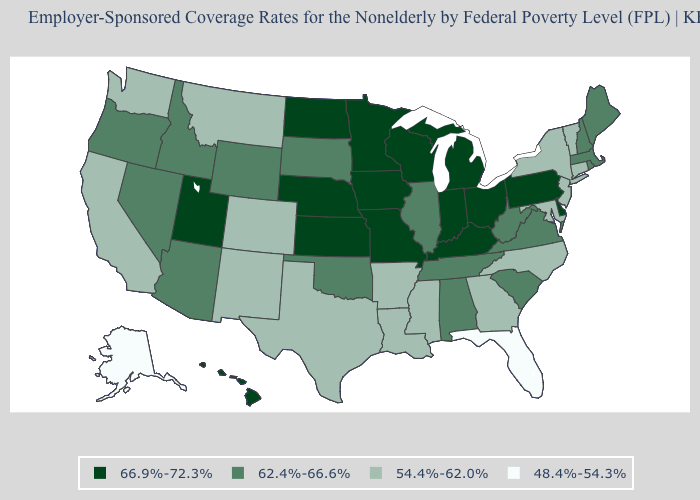Which states have the lowest value in the USA?
Keep it brief. Alaska, Florida. Name the states that have a value in the range 62.4%-66.6%?
Answer briefly. Alabama, Arizona, Idaho, Illinois, Maine, Massachusetts, Nevada, New Hampshire, Oklahoma, Oregon, Rhode Island, South Carolina, South Dakota, Tennessee, Virginia, West Virginia, Wyoming. Does Vermont have a higher value than Alaska?
Keep it brief. Yes. Name the states that have a value in the range 54.4%-62.0%?
Keep it brief. Arkansas, California, Colorado, Connecticut, Georgia, Louisiana, Maryland, Mississippi, Montana, New Jersey, New Mexico, New York, North Carolina, Texas, Vermont, Washington. Does Arizona have the lowest value in the USA?
Give a very brief answer. No. Does Pennsylvania have the same value as Ohio?
Short answer required. Yes. Name the states that have a value in the range 62.4%-66.6%?
Keep it brief. Alabama, Arizona, Idaho, Illinois, Maine, Massachusetts, Nevada, New Hampshire, Oklahoma, Oregon, Rhode Island, South Carolina, South Dakota, Tennessee, Virginia, West Virginia, Wyoming. Name the states that have a value in the range 62.4%-66.6%?
Short answer required. Alabama, Arizona, Idaho, Illinois, Maine, Massachusetts, Nevada, New Hampshire, Oklahoma, Oregon, Rhode Island, South Carolina, South Dakota, Tennessee, Virginia, West Virginia, Wyoming. Name the states that have a value in the range 66.9%-72.3%?
Keep it brief. Delaware, Hawaii, Indiana, Iowa, Kansas, Kentucky, Michigan, Minnesota, Missouri, Nebraska, North Dakota, Ohio, Pennsylvania, Utah, Wisconsin. What is the value of Georgia?
Write a very short answer. 54.4%-62.0%. Does Kansas have the highest value in the USA?
Be succinct. Yes. Name the states that have a value in the range 62.4%-66.6%?
Concise answer only. Alabama, Arizona, Idaho, Illinois, Maine, Massachusetts, Nevada, New Hampshire, Oklahoma, Oregon, Rhode Island, South Carolina, South Dakota, Tennessee, Virginia, West Virginia, Wyoming. Does Oklahoma have the highest value in the South?
Answer briefly. No. What is the value of New York?
Answer briefly. 54.4%-62.0%. Name the states that have a value in the range 54.4%-62.0%?
Give a very brief answer. Arkansas, California, Colorado, Connecticut, Georgia, Louisiana, Maryland, Mississippi, Montana, New Jersey, New Mexico, New York, North Carolina, Texas, Vermont, Washington. 